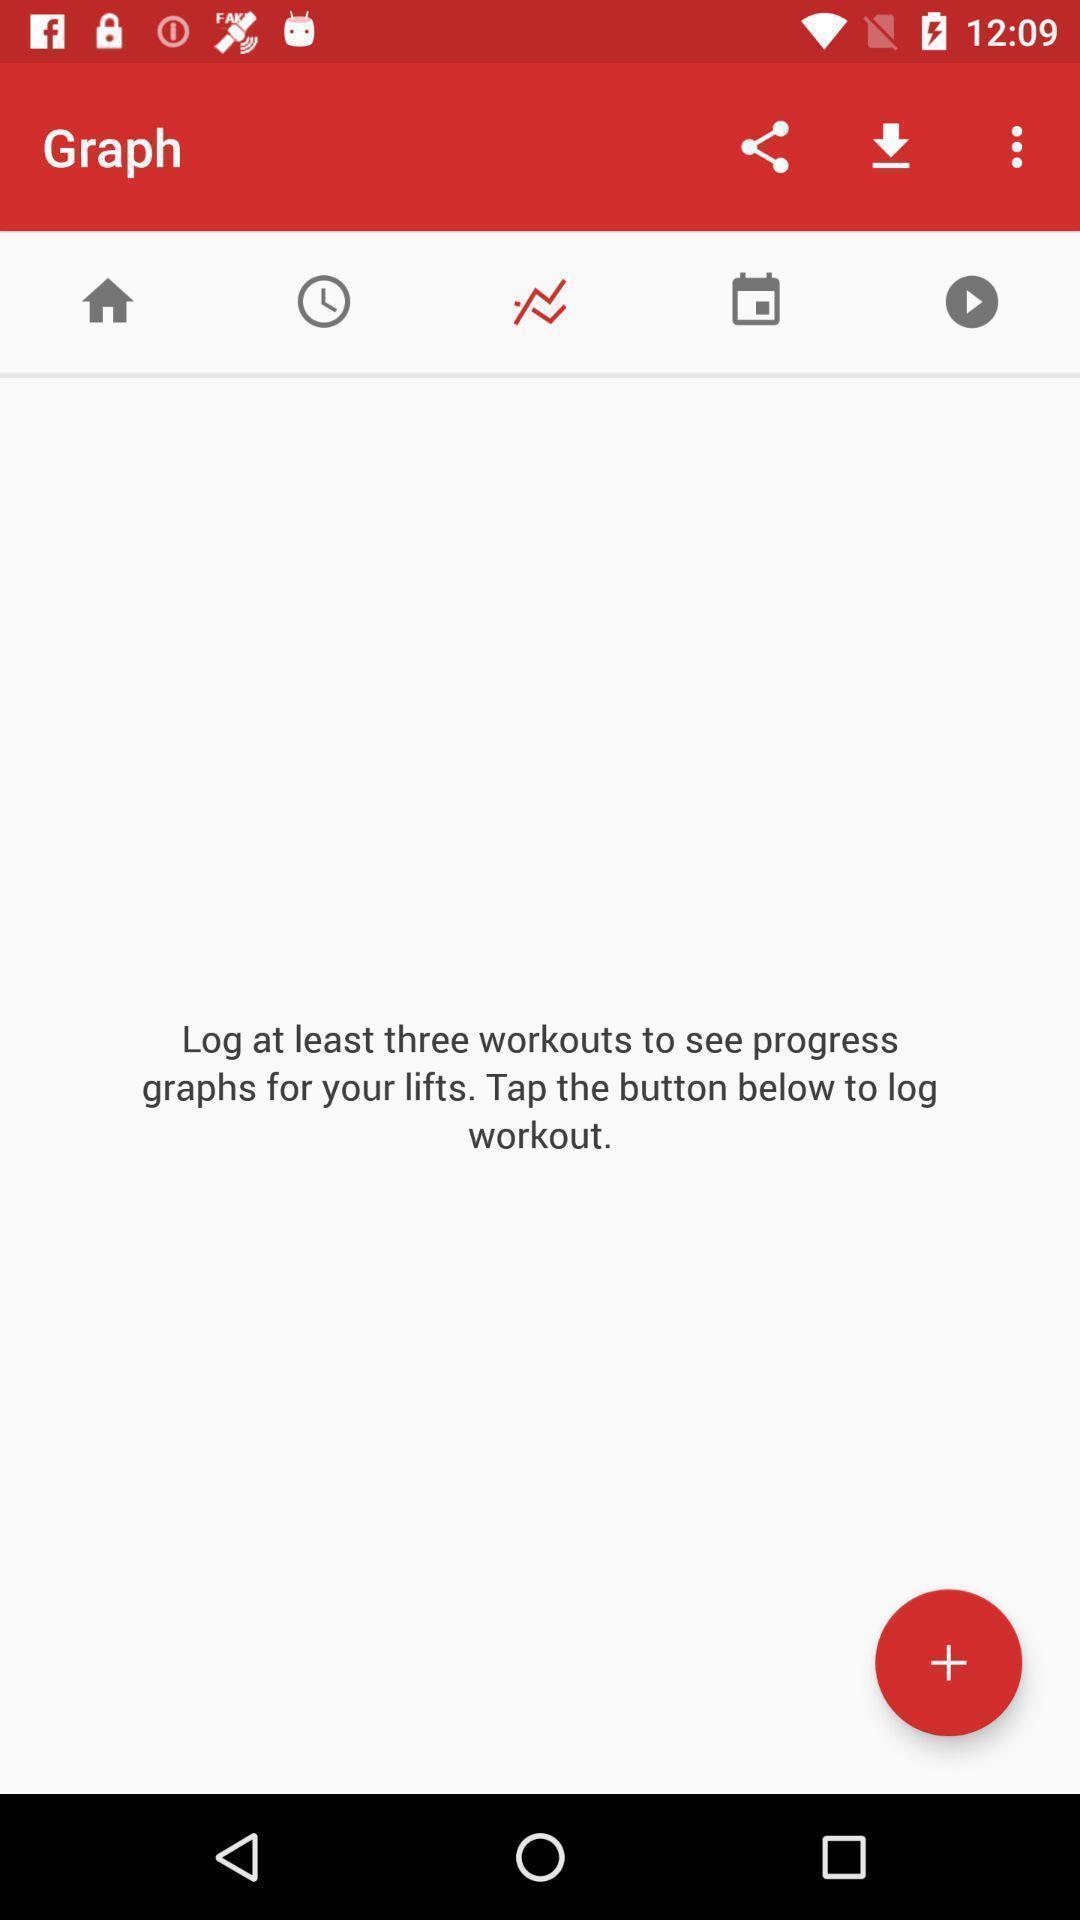What details can you identify in this image? Screen displaying log details in a fitness app. 